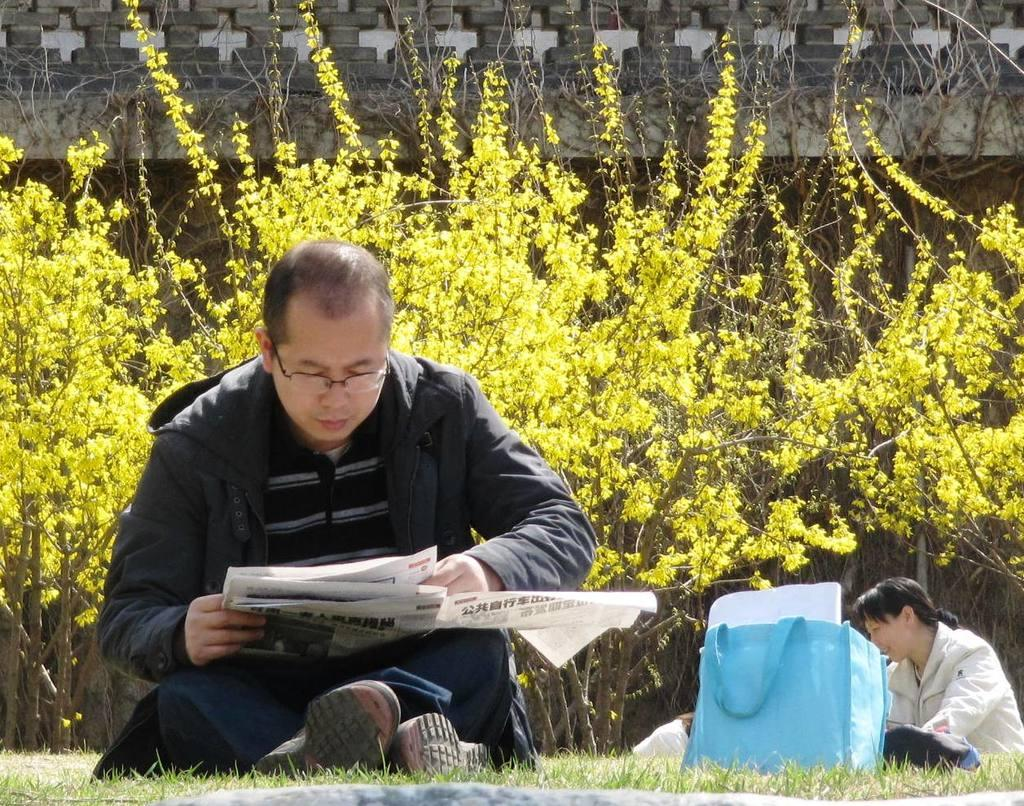What is the man in the image doing? The man is sitting and reading a newspaper in the image. What is the lady in the image holding? The lady has a bag in the image. What can be seen in the background of the image? There are trees and a wall in the background of the image. What type of pleasure can be seen in the image? There is no specific pleasure depicted in the image; it shows a man reading a newspaper and a lady with a bag. Is there any wine visible in the image? There is no wine present in the image. 